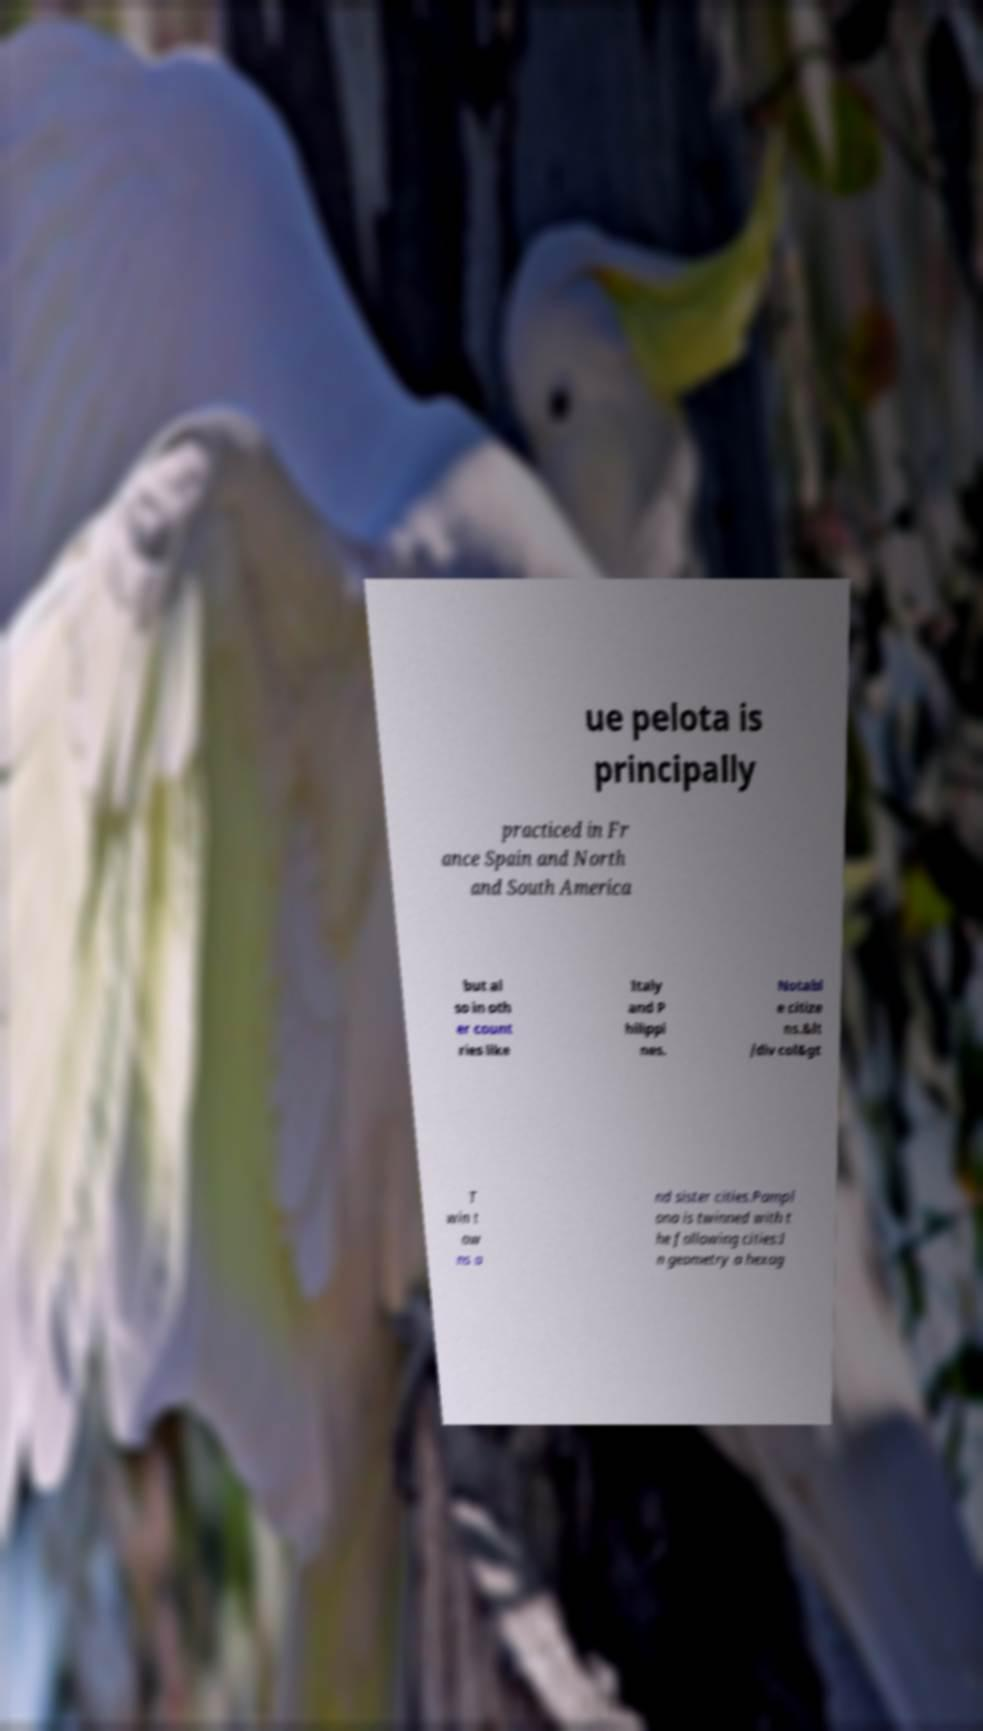Could you extract and type out the text from this image? ue pelota is principally practiced in Fr ance Spain and North and South America but al so in oth er count ries like Italy and P hilippi nes. Notabl e citize ns.&lt /div col&gt T win t ow ns a nd sister cities.Pampl ona is twinned with t he following cities:I n geometry a hexag 